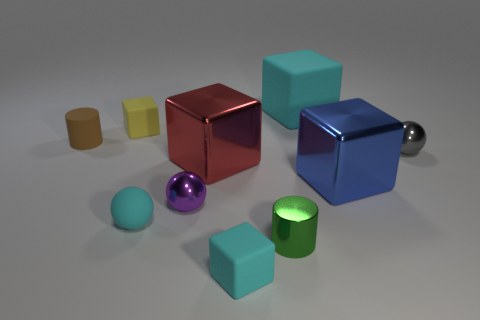Are there any small brown things made of the same material as the cyan sphere? Upon inspecting the image, it appears there are no small brown objects that match the material of the cyan sphere. The cyan sphere has a unique glossy texture that isn't replicated in any brown objects present in the picture. 